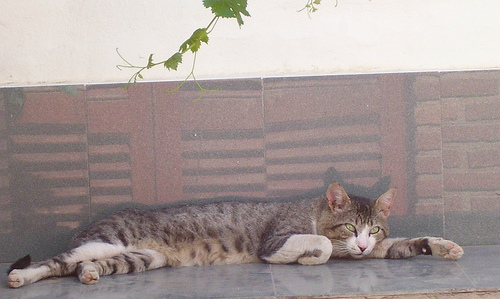<image>
Can you confirm if the cat is on the floor? Yes. Looking at the image, I can see the cat is positioned on top of the floor, with the floor providing support. Is there a cat behind the building? Yes. From this viewpoint, the cat is positioned behind the building, with the building partially or fully occluding the cat. 